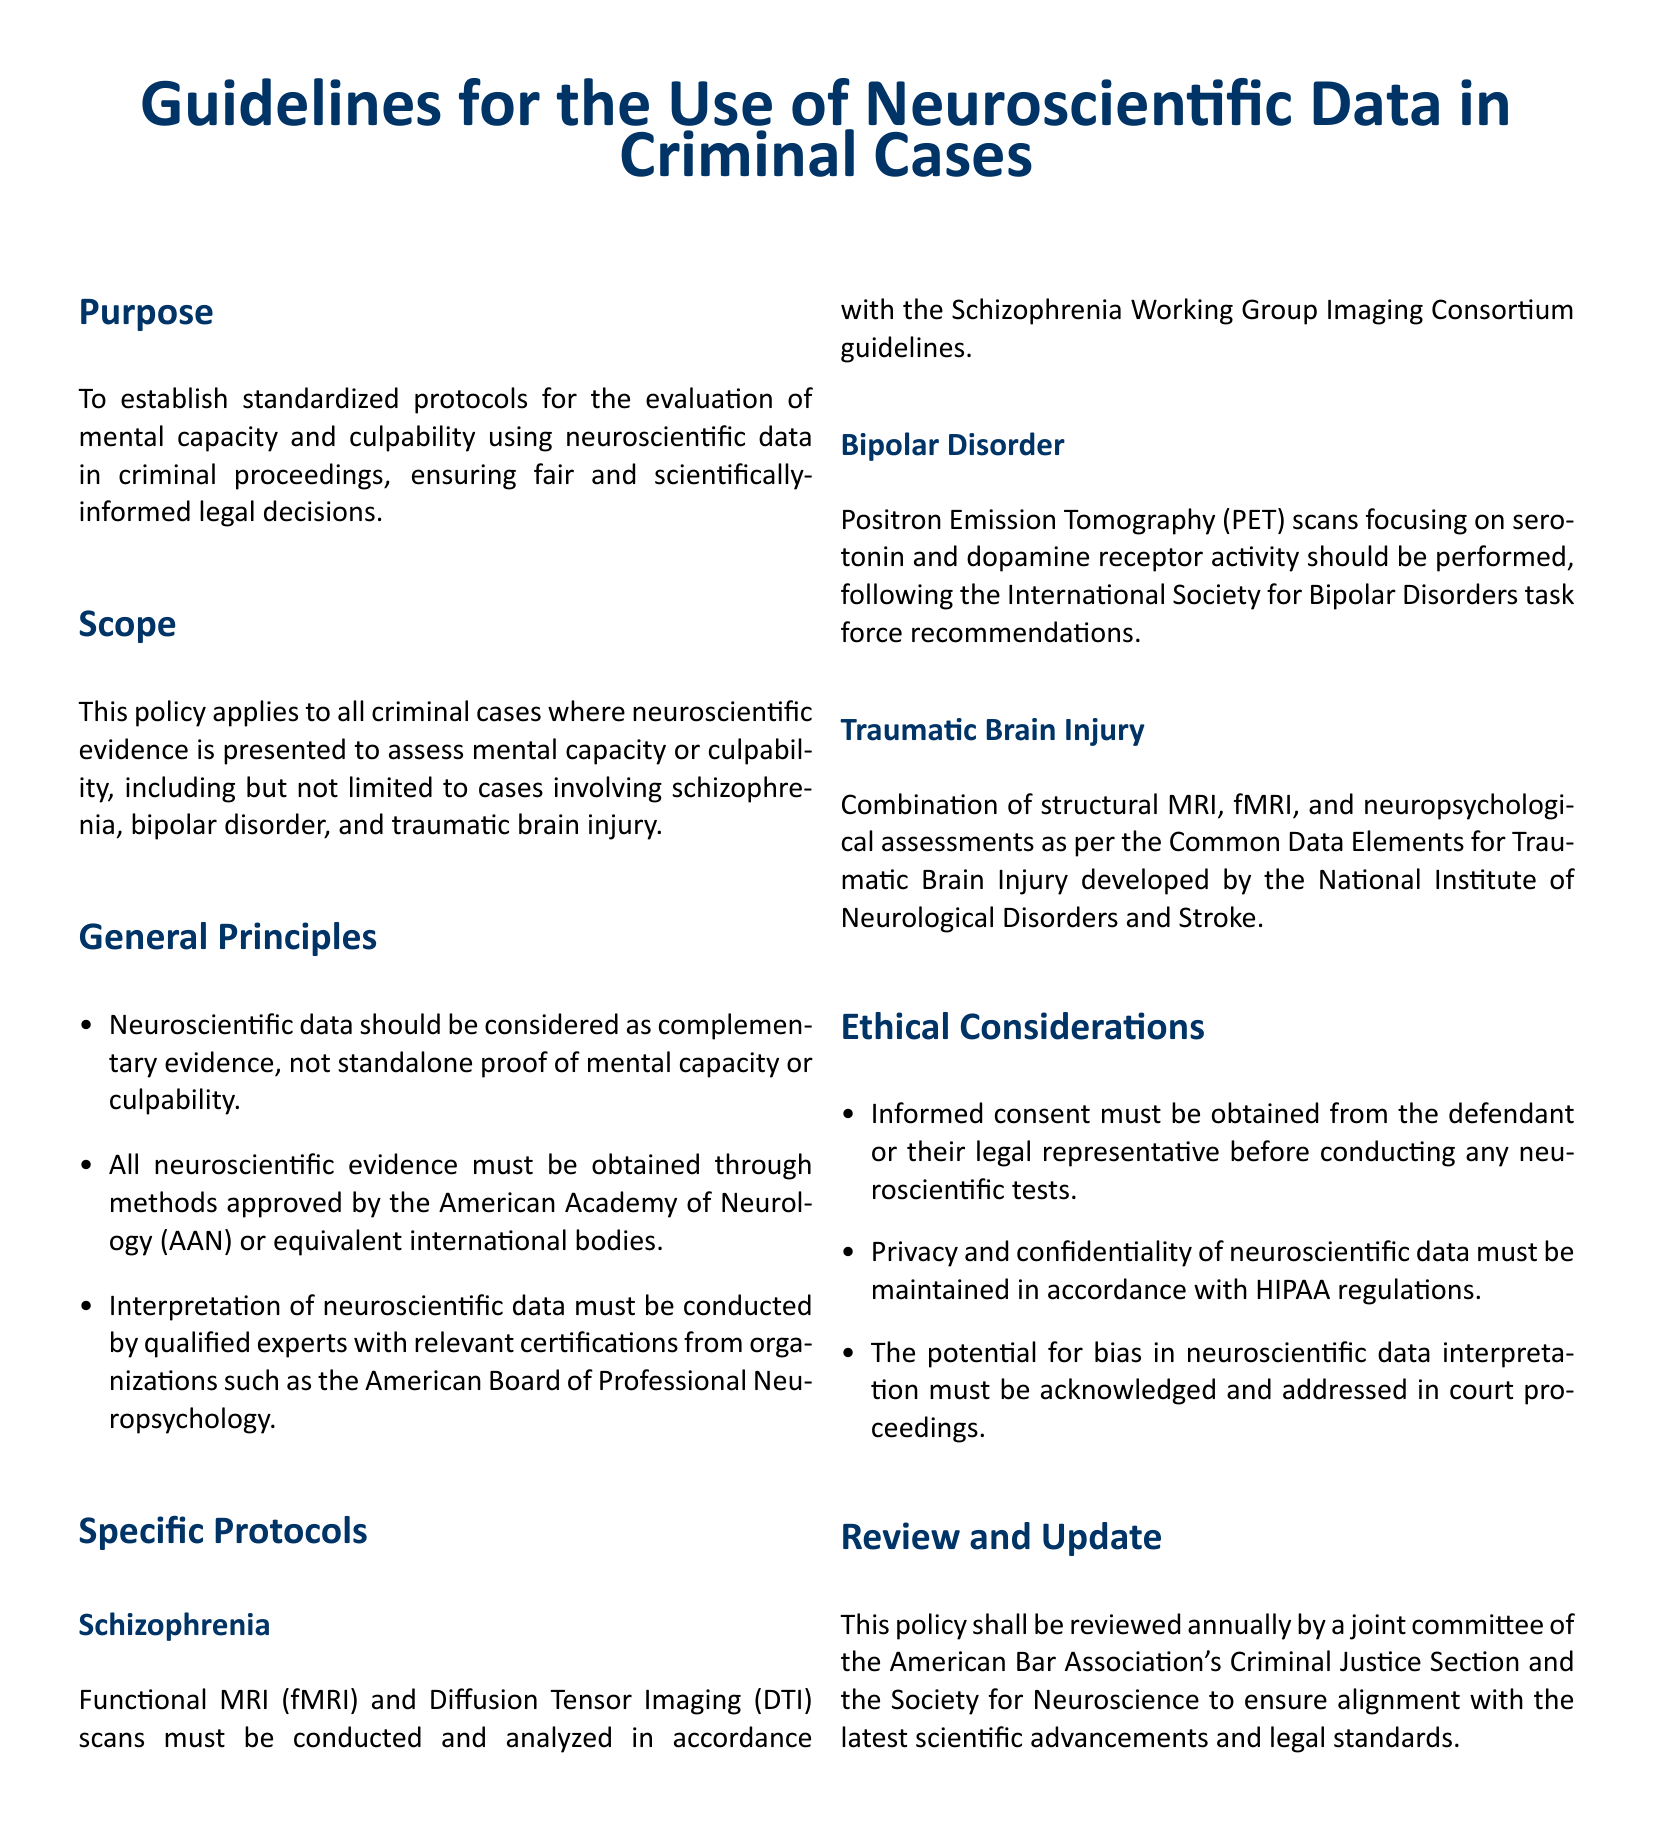What is the purpose of the guidelines? The purpose is stated clearly in the document as establishing standardized protocols for the evaluation of mental capacity and culpability using neuroscientific data in criminal proceedings.
Answer: To establish standardized protocols for the evaluation of mental capacity and culpability using neuroscientific data in criminal proceedings Which body’s guidelines must be followed for schizophrenia evaluations? The document specifies that evaluations for schizophrenia must follow the guidelines of the Schizophrenia Working Group Imaging Consortium.
Answer: Schizophrenia Working Group Imaging Consortium What type of scans are required for bipolar disorder? The document mentions that Positron Emission Tomography (PET) scans focusing on serotonin and dopamine receptor activity are required for bipolar disorder.
Answer: Positron Emission Tomography (PET) Who is responsible for interpreting the neuroscientific data? According to the document, interpreting neuroscientific data must be conducted by qualified experts with relevant certifications.
Answer: Qualified experts What information must be obtained before conducting neuroscientific tests? It is required to obtain informed consent from the defendant or their legal representative before conducting any tests, as stated in the ethical considerations.
Answer: Informed consent How often will the policy be reviewed? The policy is stated to be reviewed annually by a joint committee, which indicates the frequency of the policy review.
Answer: Annually 